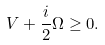<formula> <loc_0><loc_0><loc_500><loc_500>V + \frac { i } { 2 } \Omega \geq 0 .</formula> 